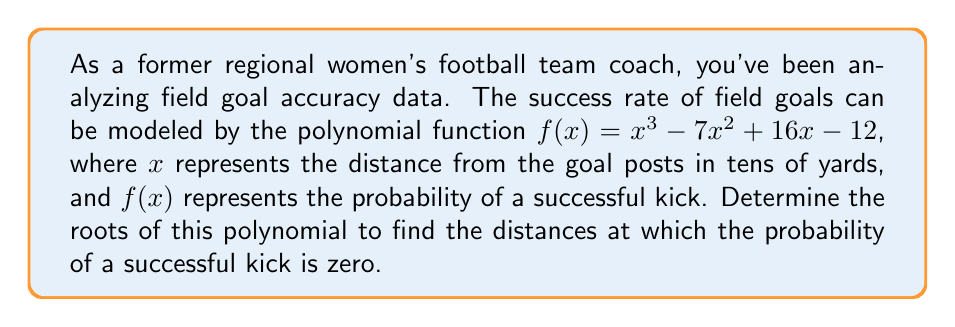Could you help me with this problem? To find the roots of the polynomial $f(x) = x^3 - 7x^2 + 16x - 12$, we need to factor it.

1) First, let's check if there's a rational root using the rational root theorem. The possible rational roots are the factors of the constant term: $\pm 1, \pm 2, \pm 3, \pm 4, \pm 6, \pm 12$.

2) Testing these values, we find that $f(1) = 0$. So, $(x-1)$ is a factor.

3) We can use polynomial long division to divide $f(x)$ by $(x-1)$:

   $x^3 - 7x^2 + 16x - 12 = (x-1)(x^2 - 6x + 12)$

4) Now we need to factor the quadratic $x^2 - 6x + 12$. Let's use the quadratic formula:

   $x = \frac{-b \pm \sqrt{b^2 - 4ac}}{2a}$

   Where $a=1$, $b=-6$, and $c=12$

5) Substituting these values:

   $x = \frac{6 \pm \sqrt{36 - 48}}{2} = \frac{6 \pm \sqrt{-12}}{2} = \frac{6 \pm 2i\sqrt{3}}{2} = 3 \pm i\sqrt{3}$

6) Therefore, the complete factorization is:

   $f(x) = (x-1)(x-(3+i\sqrt{3}))(x-(3-i\sqrt{3}))$

7) The roots are $x = 1$, $x = 3+i\sqrt{3}$, and $x = 3-i\sqrt{3}$

However, in the context of field goal distances, only the real root is meaningful. The complex roots don't represent physical distances.
Answer: The polynomial has one real root: $x = 1$. This means the probability of a successful kick is zero at a distance of 10 yards from the goal posts. The other two roots are complex and don't represent physical distances in this context. 